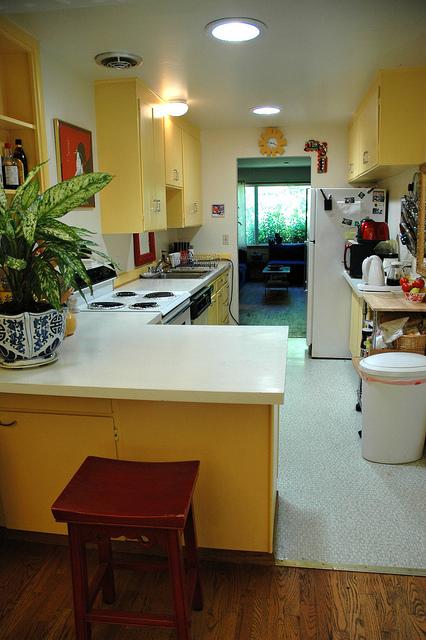What room is this?
Write a very short answer. Kitchen. What color is the garbage can?
Answer briefly. White. Are the lights on?
Concise answer only. Yes. What color is the cabinets?
Answer briefly. Yellow. What color is the microwave?
Short answer required. Black. 